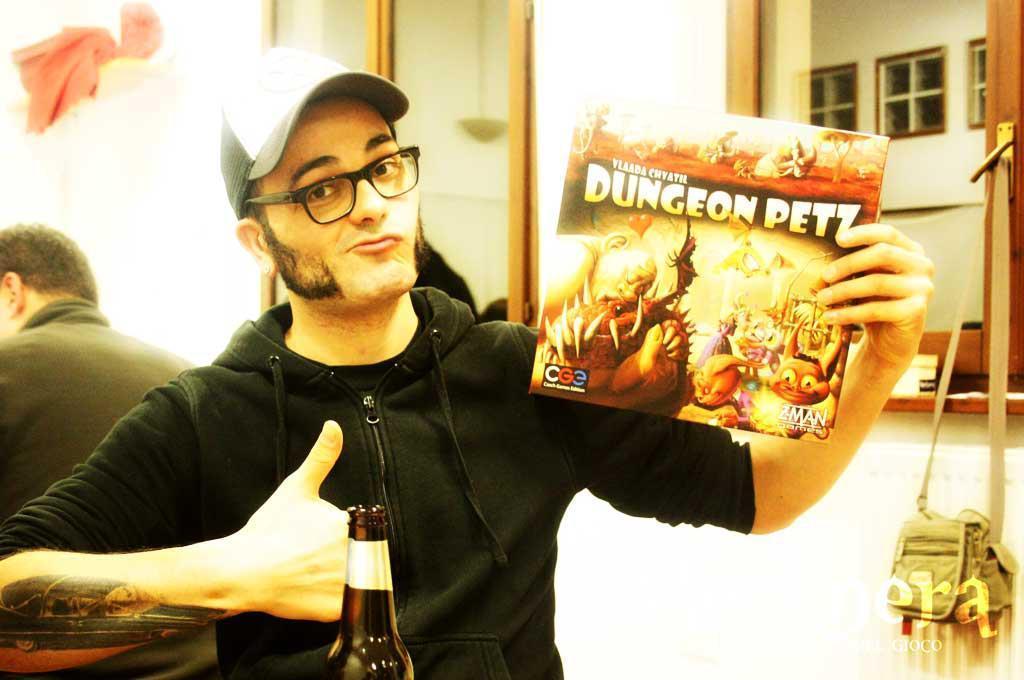How would you summarize this image in a sentence or two? In this image we can see this person wearing black sweater, spectacles and cap is holding a card in his hand. Here we can see a bottle and tattoo on his hand. In the background, we can see this person, glass windows and a bag here. 